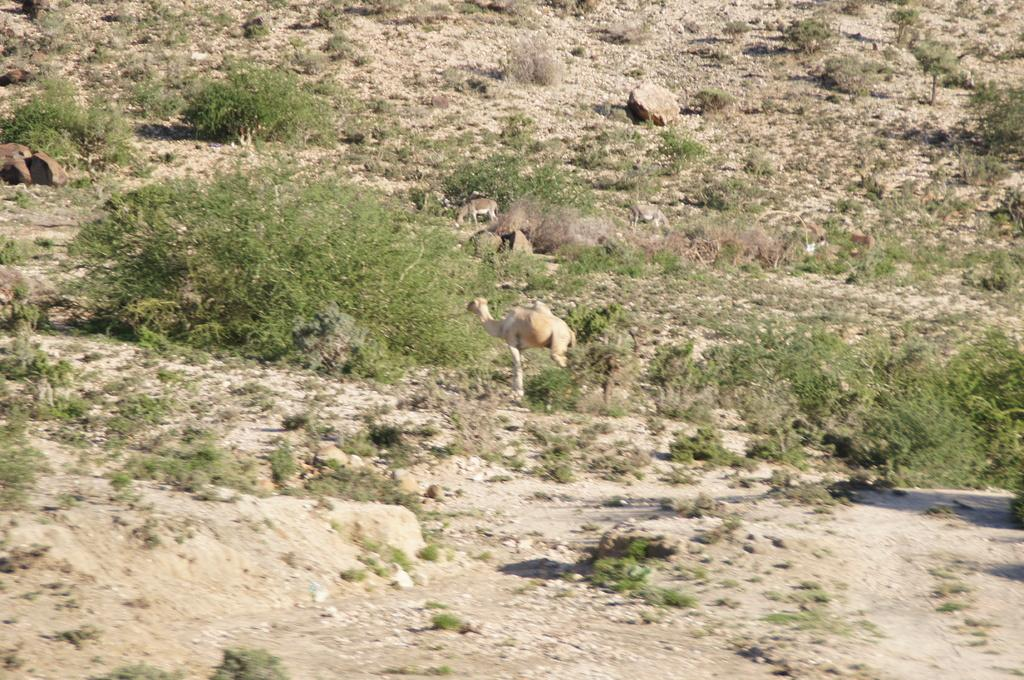What type of living organisms can be seen in the image? A: There are animals in the image. Where are the animals located in the image? The animals are on the ground. What type of vegetation is visible in the image? There is grass visible in the image. What other objects can be seen in the image besides the animals and grass? There are rocks in the image. What type of guitar can be seen hanging on the curtain in the image? There is no guitar or curtain present in the image; it features animals on the ground with grass and rocks. Can you tell me how many toothbrushes are visible in the image? There are no toothbrushes present in the image. 